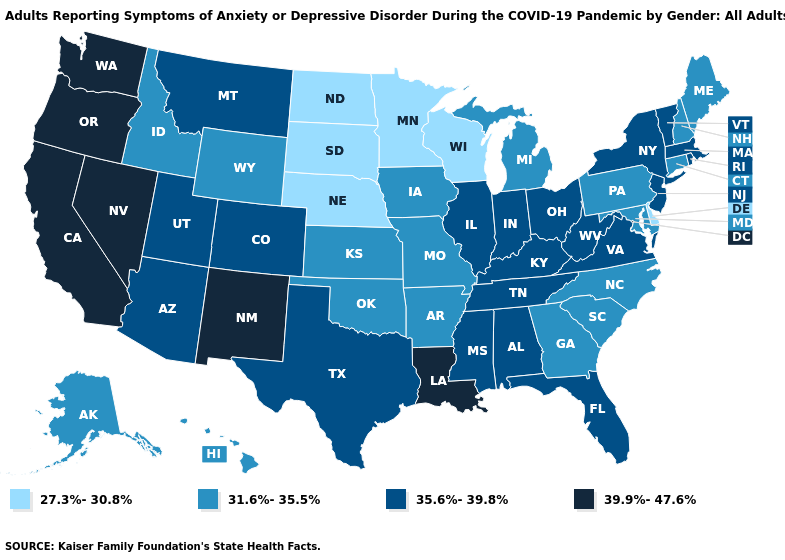Does the map have missing data?
Write a very short answer. No. Name the states that have a value in the range 39.9%-47.6%?
Write a very short answer. California, Louisiana, Nevada, New Mexico, Oregon, Washington. Which states have the lowest value in the USA?
Keep it brief. Delaware, Minnesota, Nebraska, North Dakota, South Dakota, Wisconsin. What is the highest value in the Northeast ?
Concise answer only. 35.6%-39.8%. Does Michigan have a lower value than Ohio?
Short answer required. Yes. Does the first symbol in the legend represent the smallest category?
Write a very short answer. Yes. Name the states that have a value in the range 35.6%-39.8%?
Answer briefly. Alabama, Arizona, Colorado, Florida, Illinois, Indiana, Kentucky, Massachusetts, Mississippi, Montana, New Jersey, New York, Ohio, Rhode Island, Tennessee, Texas, Utah, Vermont, Virginia, West Virginia. Among the states that border Texas , which have the highest value?
Answer briefly. Louisiana, New Mexico. What is the lowest value in the West?
Quick response, please. 31.6%-35.5%. What is the lowest value in the USA?
Write a very short answer. 27.3%-30.8%. Name the states that have a value in the range 39.9%-47.6%?
Concise answer only. California, Louisiana, Nevada, New Mexico, Oregon, Washington. Name the states that have a value in the range 31.6%-35.5%?
Short answer required. Alaska, Arkansas, Connecticut, Georgia, Hawaii, Idaho, Iowa, Kansas, Maine, Maryland, Michigan, Missouri, New Hampshire, North Carolina, Oklahoma, Pennsylvania, South Carolina, Wyoming. Name the states that have a value in the range 39.9%-47.6%?
Answer briefly. California, Louisiana, Nevada, New Mexico, Oregon, Washington. What is the value of Arizona?
Give a very brief answer. 35.6%-39.8%. What is the value of Washington?
Answer briefly. 39.9%-47.6%. 